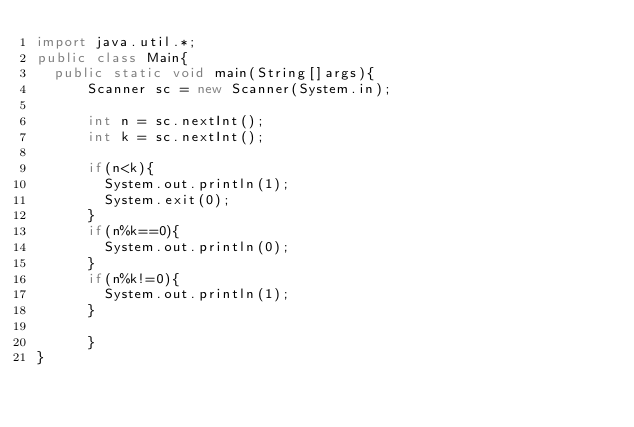Convert code to text. <code><loc_0><loc_0><loc_500><loc_500><_Java_>import java.util.*;
public class Main{
  public static void main(String[]args){
      Scanner sc = new Scanner(System.in);

      int n = sc.nextInt();
      int k = sc.nextInt();

      if(n<k){
        System.out.println(1);
        System.exit(0);
      }
      if(n%k==0){
        System.out.println(0);
      }
      if(n%k!=0){
        System.out.println(1);
      }

      }
}</code> 